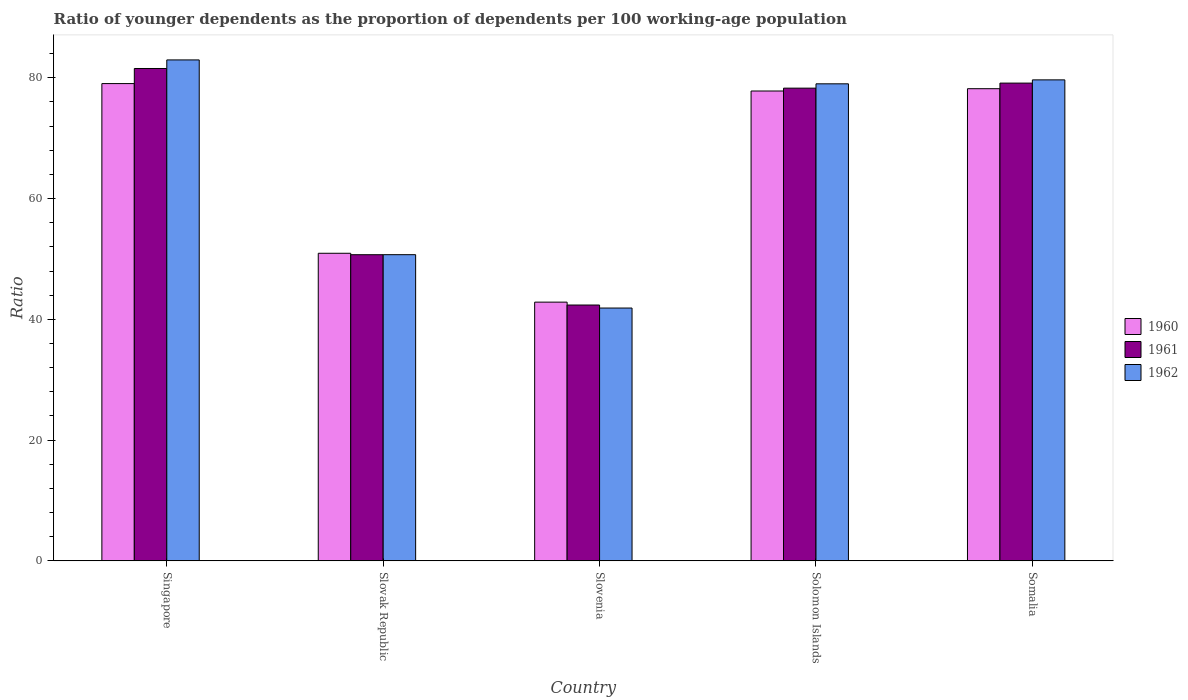Are the number of bars per tick equal to the number of legend labels?
Your answer should be very brief. Yes. Are the number of bars on each tick of the X-axis equal?
Your answer should be compact. Yes. How many bars are there on the 1st tick from the left?
Provide a short and direct response. 3. How many bars are there on the 5th tick from the right?
Your answer should be compact. 3. What is the label of the 1st group of bars from the left?
Give a very brief answer. Singapore. In how many cases, is the number of bars for a given country not equal to the number of legend labels?
Your answer should be very brief. 0. What is the age dependency ratio(young) in 1960 in Somalia?
Provide a succinct answer. 78.2. Across all countries, what is the maximum age dependency ratio(young) in 1961?
Offer a terse response. 81.54. Across all countries, what is the minimum age dependency ratio(young) in 1960?
Your answer should be compact. 42.85. In which country was the age dependency ratio(young) in 1961 maximum?
Offer a terse response. Singapore. In which country was the age dependency ratio(young) in 1960 minimum?
Your answer should be very brief. Slovenia. What is the total age dependency ratio(young) in 1962 in the graph?
Offer a terse response. 334.2. What is the difference between the age dependency ratio(young) in 1962 in Singapore and that in Somalia?
Your answer should be very brief. 3.3. What is the difference between the age dependency ratio(young) in 1960 in Slovenia and the age dependency ratio(young) in 1962 in Slovak Republic?
Ensure brevity in your answer.  -7.86. What is the average age dependency ratio(young) in 1960 per country?
Your answer should be compact. 65.77. What is the difference between the age dependency ratio(young) of/in 1962 and age dependency ratio(young) of/in 1960 in Somalia?
Provide a short and direct response. 1.46. In how many countries, is the age dependency ratio(young) in 1960 greater than 52?
Ensure brevity in your answer.  3. What is the ratio of the age dependency ratio(young) in 1961 in Slovenia to that in Solomon Islands?
Your answer should be compact. 0.54. Is the age dependency ratio(young) in 1961 in Singapore less than that in Solomon Islands?
Make the answer very short. No. Is the difference between the age dependency ratio(young) in 1962 in Singapore and Somalia greater than the difference between the age dependency ratio(young) in 1960 in Singapore and Somalia?
Offer a terse response. Yes. What is the difference between the highest and the second highest age dependency ratio(young) in 1960?
Provide a succinct answer. -0.38. What is the difference between the highest and the lowest age dependency ratio(young) in 1960?
Offer a terse response. 36.2. In how many countries, is the age dependency ratio(young) in 1962 greater than the average age dependency ratio(young) in 1962 taken over all countries?
Your answer should be compact. 3. What does the 2nd bar from the right in Slovak Republic represents?
Give a very brief answer. 1961. Are all the bars in the graph horizontal?
Keep it short and to the point. No. Are the values on the major ticks of Y-axis written in scientific E-notation?
Your response must be concise. No. Does the graph contain grids?
Your answer should be very brief. No. Where does the legend appear in the graph?
Provide a succinct answer. Center right. What is the title of the graph?
Make the answer very short. Ratio of younger dependents as the proportion of dependents per 100 working-age population. Does "1987" appear as one of the legend labels in the graph?
Offer a terse response. No. What is the label or title of the X-axis?
Ensure brevity in your answer.  Country. What is the label or title of the Y-axis?
Give a very brief answer. Ratio. What is the Ratio of 1960 in Singapore?
Your answer should be compact. 79.04. What is the Ratio in 1961 in Singapore?
Provide a succinct answer. 81.54. What is the Ratio of 1962 in Singapore?
Provide a succinct answer. 82.96. What is the Ratio of 1960 in Slovak Republic?
Keep it short and to the point. 50.94. What is the Ratio of 1961 in Slovak Republic?
Ensure brevity in your answer.  50.7. What is the Ratio in 1962 in Slovak Republic?
Keep it short and to the point. 50.71. What is the Ratio in 1960 in Slovenia?
Keep it short and to the point. 42.85. What is the Ratio in 1961 in Slovenia?
Offer a very short reply. 42.37. What is the Ratio in 1962 in Slovenia?
Make the answer very short. 41.87. What is the Ratio of 1960 in Solomon Islands?
Keep it short and to the point. 77.81. What is the Ratio in 1961 in Solomon Islands?
Provide a short and direct response. 78.29. What is the Ratio in 1962 in Solomon Islands?
Offer a very short reply. 79.01. What is the Ratio in 1960 in Somalia?
Ensure brevity in your answer.  78.2. What is the Ratio of 1961 in Somalia?
Your answer should be very brief. 79.12. What is the Ratio of 1962 in Somalia?
Give a very brief answer. 79.66. Across all countries, what is the maximum Ratio of 1960?
Your response must be concise. 79.04. Across all countries, what is the maximum Ratio in 1961?
Give a very brief answer. 81.54. Across all countries, what is the maximum Ratio of 1962?
Your answer should be compact. 82.96. Across all countries, what is the minimum Ratio of 1960?
Your answer should be very brief. 42.85. Across all countries, what is the minimum Ratio in 1961?
Offer a terse response. 42.37. Across all countries, what is the minimum Ratio in 1962?
Your answer should be compact. 41.87. What is the total Ratio in 1960 in the graph?
Make the answer very short. 328.84. What is the total Ratio in 1961 in the graph?
Your answer should be very brief. 332.03. What is the total Ratio of 1962 in the graph?
Make the answer very short. 334.2. What is the difference between the Ratio in 1960 in Singapore and that in Slovak Republic?
Provide a short and direct response. 28.1. What is the difference between the Ratio of 1961 in Singapore and that in Slovak Republic?
Make the answer very short. 30.84. What is the difference between the Ratio in 1962 in Singapore and that in Slovak Republic?
Ensure brevity in your answer.  32.26. What is the difference between the Ratio of 1960 in Singapore and that in Slovenia?
Offer a very short reply. 36.2. What is the difference between the Ratio in 1961 in Singapore and that in Slovenia?
Ensure brevity in your answer.  39.17. What is the difference between the Ratio in 1962 in Singapore and that in Slovenia?
Offer a terse response. 41.09. What is the difference between the Ratio in 1960 in Singapore and that in Solomon Islands?
Your answer should be compact. 1.23. What is the difference between the Ratio in 1961 in Singapore and that in Solomon Islands?
Provide a short and direct response. 3.26. What is the difference between the Ratio of 1962 in Singapore and that in Solomon Islands?
Provide a short and direct response. 3.96. What is the difference between the Ratio in 1960 in Singapore and that in Somalia?
Provide a succinct answer. 0.85. What is the difference between the Ratio of 1961 in Singapore and that in Somalia?
Your answer should be compact. 2.42. What is the difference between the Ratio in 1962 in Singapore and that in Somalia?
Offer a very short reply. 3.3. What is the difference between the Ratio of 1960 in Slovak Republic and that in Slovenia?
Give a very brief answer. 8.09. What is the difference between the Ratio in 1961 in Slovak Republic and that in Slovenia?
Provide a short and direct response. 8.33. What is the difference between the Ratio in 1962 in Slovak Republic and that in Slovenia?
Your answer should be compact. 8.84. What is the difference between the Ratio in 1960 in Slovak Republic and that in Solomon Islands?
Make the answer very short. -26.87. What is the difference between the Ratio in 1961 in Slovak Republic and that in Solomon Islands?
Your answer should be very brief. -27.59. What is the difference between the Ratio of 1962 in Slovak Republic and that in Solomon Islands?
Make the answer very short. -28.3. What is the difference between the Ratio in 1960 in Slovak Republic and that in Somalia?
Your response must be concise. -27.26. What is the difference between the Ratio of 1961 in Slovak Republic and that in Somalia?
Offer a very short reply. -28.42. What is the difference between the Ratio in 1962 in Slovak Republic and that in Somalia?
Ensure brevity in your answer.  -28.95. What is the difference between the Ratio of 1960 in Slovenia and that in Solomon Islands?
Provide a succinct answer. -34.97. What is the difference between the Ratio in 1961 in Slovenia and that in Solomon Islands?
Offer a terse response. -35.92. What is the difference between the Ratio in 1962 in Slovenia and that in Solomon Islands?
Offer a very short reply. -37.14. What is the difference between the Ratio in 1960 in Slovenia and that in Somalia?
Give a very brief answer. -35.35. What is the difference between the Ratio in 1961 in Slovenia and that in Somalia?
Offer a terse response. -36.76. What is the difference between the Ratio of 1962 in Slovenia and that in Somalia?
Make the answer very short. -37.79. What is the difference between the Ratio in 1960 in Solomon Islands and that in Somalia?
Make the answer very short. -0.38. What is the difference between the Ratio in 1961 in Solomon Islands and that in Somalia?
Your answer should be very brief. -0.84. What is the difference between the Ratio of 1962 in Solomon Islands and that in Somalia?
Provide a short and direct response. -0.65. What is the difference between the Ratio in 1960 in Singapore and the Ratio in 1961 in Slovak Republic?
Offer a terse response. 28.34. What is the difference between the Ratio in 1960 in Singapore and the Ratio in 1962 in Slovak Republic?
Your answer should be compact. 28.34. What is the difference between the Ratio in 1961 in Singapore and the Ratio in 1962 in Slovak Republic?
Provide a short and direct response. 30.84. What is the difference between the Ratio of 1960 in Singapore and the Ratio of 1961 in Slovenia?
Your answer should be compact. 36.67. What is the difference between the Ratio in 1960 in Singapore and the Ratio in 1962 in Slovenia?
Your answer should be very brief. 37.17. What is the difference between the Ratio in 1961 in Singapore and the Ratio in 1962 in Slovenia?
Ensure brevity in your answer.  39.67. What is the difference between the Ratio of 1960 in Singapore and the Ratio of 1961 in Solomon Islands?
Offer a terse response. 0.76. What is the difference between the Ratio of 1960 in Singapore and the Ratio of 1962 in Solomon Islands?
Make the answer very short. 0.04. What is the difference between the Ratio of 1961 in Singapore and the Ratio of 1962 in Solomon Islands?
Provide a short and direct response. 2.54. What is the difference between the Ratio of 1960 in Singapore and the Ratio of 1961 in Somalia?
Your answer should be very brief. -0.08. What is the difference between the Ratio of 1960 in Singapore and the Ratio of 1962 in Somalia?
Your response must be concise. -0.62. What is the difference between the Ratio of 1961 in Singapore and the Ratio of 1962 in Somalia?
Your response must be concise. 1.88. What is the difference between the Ratio in 1960 in Slovak Republic and the Ratio in 1961 in Slovenia?
Make the answer very short. 8.57. What is the difference between the Ratio of 1960 in Slovak Republic and the Ratio of 1962 in Slovenia?
Keep it short and to the point. 9.07. What is the difference between the Ratio in 1961 in Slovak Republic and the Ratio in 1962 in Slovenia?
Your answer should be very brief. 8.83. What is the difference between the Ratio of 1960 in Slovak Republic and the Ratio of 1961 in Solomon Islands?
Your response must be concise. -27.35. What is the difference between the Ratio in 1960 in Slovak Republic and the Ratio in 1962 in Solomon Islands?
Offer a terse response. -28.07. What is the difference between the Ratio in 1961 in Slovak Republic and the Ratio in 1962 in Solomon Islands?
Keep it short and to the point. -28.3. What is the difference between the Ratio of 1960 in Slovak Republic and the Ratio of 1961 in Somalia?
Offer a terse response. -28.18. What is the difference between the Ratio in 1960 in Slovak Republic and the Ratio in 1962 in Somalia?
Your response must be concise. -28.72. What is the difference between the Ratio of 1961 in Slovak Republic and the Ratio of 1962 in Somalia?
Your answer should be compact. -28.96. What is the difference between the Ratio in 1960 in Slovenia and the Ratio in 1961 in Solomon Islands?
Provide a succinct answer. -35.44. What is the difference between the Ratio in 1960 in Slovenia and the Ratio in 1962 in Solomon Islands?
Provide a succinct answer. -36.16. What is the difference between the Ratio of 1961 in Slovenia and the Ratio of 1962 in Solomon Islands?
Offer a very short reply. -36.64. What is the difference between the Ratio in 1960 in Slovenia and the Ratio in 1961 in Somalia?
Your response must be concise. -36.28. What is the difference between the Ratio of 1960 in Slovenia and the Ratio of 1962 in Somalia?
Give a very brief answer. -36.81. What is the difference between the Ratio of 1961 in Slovenia and the Ratio of 1962 in Somalia?
Provide a short and direct response. -37.29. What is the difference between the Ratio of 1960 in Solomon Islands and the Ratio of 1961 in Somalia?
Provide a succinct answer. -1.31. What is the difference between the Ratio in 1960 in Solomon Islands and the Ratio in 1962 in Somalia?
Offer a very short reply. -1.85. What is the difference between the Ratio in 1961 in Solomon Islands and the Ratio in 1962 in Somalia?
Offer a terse response. -1.37. What is the average Ratio in 1960 per country?
Your answer should be very brief. 65.77. What is the average Ratio of 1961 per country?
Ensure brevity in your answer.  66.41. What is the average Ratio in 1962 per country?
Offer a very short reply. 66.84. What is the difference between the Ratio in 1960 and Ratio in 1961 in Singapore?
Ensure brevity in your answer.  -2.5. What is the difference between the Ratio of 1960 and Ratio of 1962 in Singapore?
Keep it short and to the point. -3.92. What is the difference between the Ratio of 1961 and Ratio of 1962 in Singapore?
Your response must be concise. -1.42. What is the difference between the Ratio in 1960 and Ratio in 1961 in Slovak Republic?
Provide a succinct answer. 0.24. What is the difference between the Ratio of 1960 and Ratio of 1962 in Slovak Republic?
Make the answer very short. 0.23. What is the difference between the Ratio of 1961 and Ratio of 1962 in Slovak Republic?
Offer a very short reply. -0.01. What is the difference between the Ratio in 1960 and Ratio in 1961 in Slovenia?
Ensure brevity in your answer.  0.48. What is the difference between the Ratio in 1960 and Ratio in 1962 in Slovenia?
Your answer should be compact. 0.98. What is the difference between the Ratio of 1961 and Ratio of 1962 in Slovenia?
Offer a terse response. 0.5. What is the difference between the Ratio in 1960 and Ratio in 1961 in Solomon Islands?
Your answer should be compact. -0.47. What is the difference between the Ratio in 1960 and Ratio in 1962 in Solomon Islands?
Provide a short and direct response. -1.19. What is the difference between the Ratio of 1961 and Ratio of 1962 in Solomon Islands?
Make the answer very short. -0.72. What is the difference between the Ratio in 1960 and Ratio in 1961 in Somalia?
Give a very brief answer. -0.93. What is the difference between the Ratio of 1960 and Ratio of 1962 in Somalia?
Your response must be concise. -1.46. What is the difference between the Ratio of 1961 and Ratio of 1962 in Somalia?
Your answer should be compact. -0.53. What is the ratio of the Ratio of 1960 in Singapore to that in Slovak Republic?
Offer a terse response. 1.55. What is the ratio of the Ratio of 1961 in Singapore to that in Slovak Republic?
Your response must be concise. 1.61. What is the ratio of the Ratio of 1962 in Singapore to that in Slovak Republic?
Ensure brevity in your answer.  1.64. What is the ratio of the Ratio in 1960 in Singapore to that in Slovenia?
Provide a succinct answer. 1.84. What is the ratio of the Ratio of 1961 in Singapore to that in Slovenia?
Your answer should be compact. 1.92. What is the ratio of the Ratio in 1962 in Singapore to that in Slovenia?
Your answer should be compact. 1.98. What is the ratio of the Ratio of 1960 in Singapore to that in Solomon Islands?
Provide a succinct answer. 1.02. What is the ratio of the Ratio of 1961 in Singapore to that in Solomon Islands?
Provide a succinct answer. 1.04. What is the ratio of the Ratio of 1962 in Singapore to that in Solomon Islands?
Your answer should be very brief. 1.05. What is the ratio of the Ratio in 1960 in Singapore to that in Somalia?
Your response must be concise. 1.01. What is the ratio of the Ratio in 1961 in Singapore to that in Somalia?
Provide a succinct answer. 1.03. What is the ratio of the Ratio in 1962 in Singapore to that in Somalia?
Your answer should be very brief. 1.04. What is the ratio of the Ratio of 1960 in Slovak Republic to that in Slovenia?
Offer a very short reply. 1.19. What is the ratio of the Ratio of 1961 in Slovak Republic to that in Slovenia?
Provide a succinct answer. 1.2. What is the ratio of the Ratio in 1962 in Slovak Republic to that in Slovenia?
Give a very brief answer. 1.21. What is the ratio of the Ratio in 1960 in Slovak Republic to that in Solomon Islands?
Your answer should be very brief. 0.65. What is the ratio of the Ratio in 1961 in Slovak Republic to that in Solomon Islands?
Offer a very short reply. 0.65. What is the ratio of the Ratio in 1962 in Slovak Republic to that in Solomon Islands?
Offer a very short reply. 0.64. What is the ratio of the Ratio of 1960 in Slovak Republic to that in Somalia?
Make the answer very short. 0.65. What is the ratio of the Ratio of 1961 in Slovak Republic to that in Somalia?
Provide a short and direct response. 0.64. What is the ratio of the Ratio of 1962 in Slovak Republic to that in Somalia?
Make the answer very short. 0.64. What is the ratio of the Ratio in 1960 in Slovenia to that in Solomon Islands?
Ensure brevity in your answer.  0.55. What is the ratio of the Ratio in 1961 in Slovenia to that in Solomon Islands?
Make the answer very short. 0.54. What is the ratio of the Ratio in 1962 in Slovenia to that in Solomon Islands?
Keep it short and to the point. 0.53. What is the ratio of the Ratio of 1960 in Slovenia to that in Somalia?
Provide a short and direct response. 0.55. What is the ratio of the Ratio in 1961 in Slovenia to that in Somalia?
Give a very brief answer. 0.54. What is the ratio of the Ratio of 1962 in Slovenia to that in Somalia?
Your answer should be very brief. 0.53. What is the ratio of the Ratio in 1960 in Solomon Islands to that in Somalia?
Make the answer very short. 1. What is the difference between the highest and the second highest Ratio of 1960?
Ensure brevity in your answer.  0.85. What is the difference between the highest and the second highest Ratio of 1961?
Your response must be concise. 2.42. What is the difference between the highest and the second highest Ratio of 1962?
Provide a short and direct response. 3.3. What is the difference between the highest and the lowest Ratio in 1960?
Provide a short and direct response. 36.2. What is the difference between the highest and the lowest Ratio in 1961?
Provide a short and direct response. 39.17. What is the difference between the highest and the lowest Ratio of 1962?
Give a very brief answer. 41.09. 